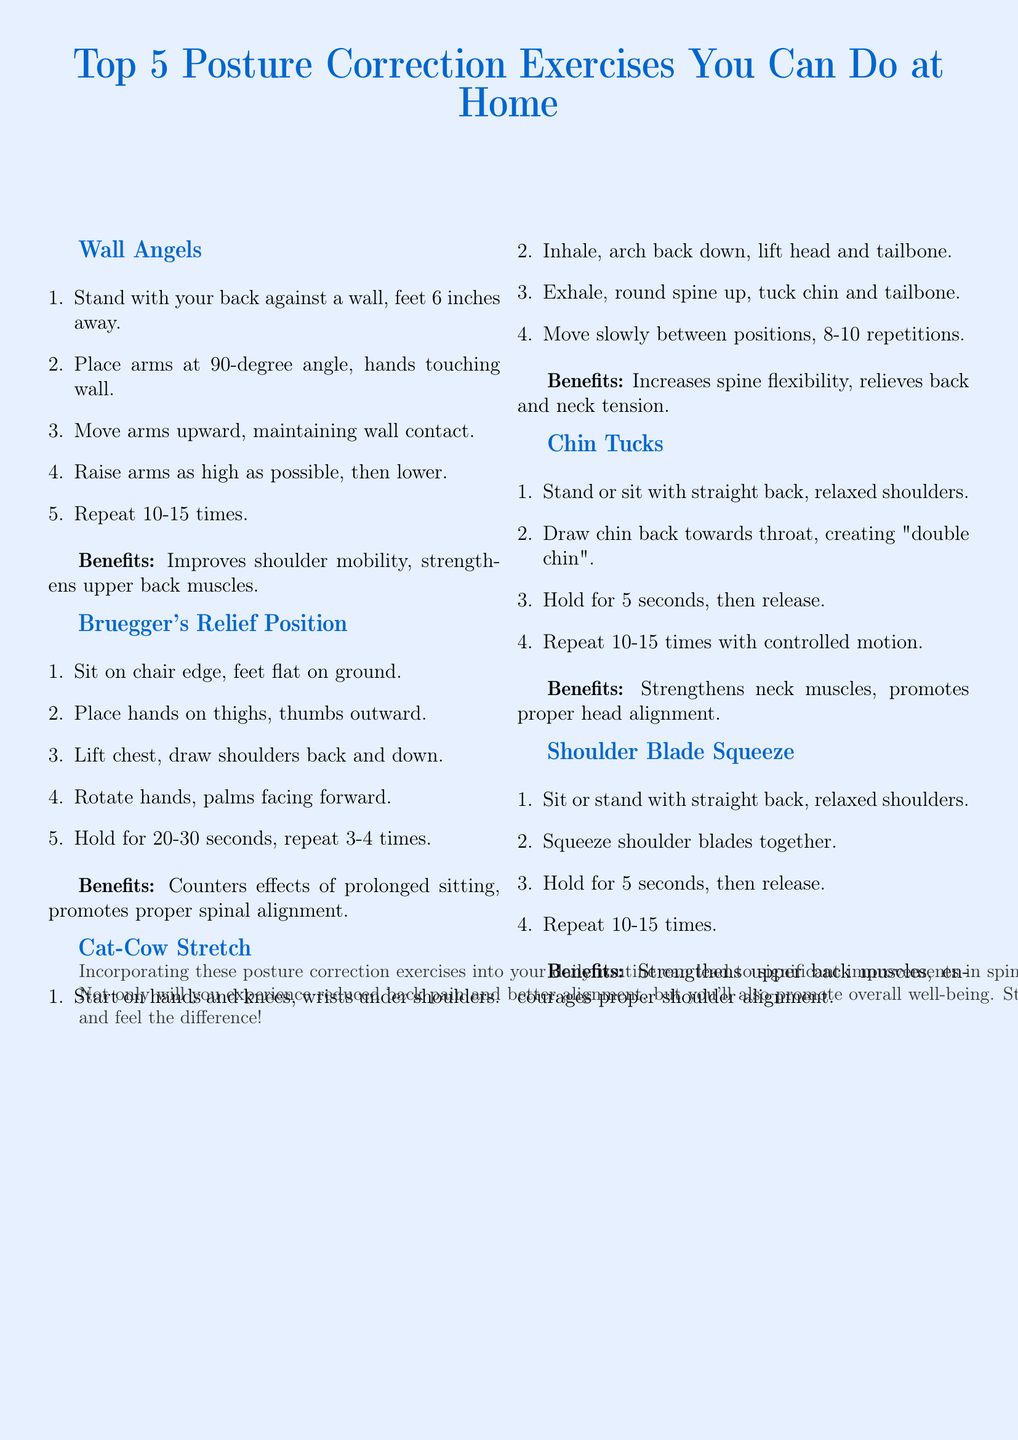What are the top posture correction exercises? The document lists the top five exercises aimed at improving posture: Wall Angels, Bruegger's Relief Position, Cat-Cow Stretch, Chin Tucks, and Shoulder Blade Squeeze.
Answer: Wall Angels, Bruegger's Relief Position, Cat-Cow Stretch, Chin Tucks, Shoulder Blade Squeeze How many repetitions are suggested for Wall Angels? The instructions for Wall Angels indicate that you should repeat the exercise 10-15 times.
Answer: 10-15 times What is a primary benefit of the Chin Tucks exercise? The document states that Chin Tucks strengthen neck muscles and promote proper head alignment.
Answer: Strengthens neck muscles, promotes proper head alignment Which exercise is recommended for improving shoulder mobility? The benefit listed for Wall Angels includes improving shoulder mobility and strengthening upper back muscles.
Answer: Wall Angels How many times should you hold the Bruegger's Relief Position? The instructions suggest holding the position for 20-30 seconds and repeating it 3-4 times.
Answer: 3-4 times What is the overall benefit of incorporating these exercises? The document explains that incorporating these exercises can lead to significant improvements in spinal health and overall well-being.
Answer: Significant improvements in spinal health What posture-related problems do these exercises target? The flyer addresses issues like back pain and improper spinal alignment, highlighting that the exercises help to relieve these problems.
Answer: Back pain, improper spinal alignment What posture correction exercise involves arching and rounding the back? The exercise that involves arching the back down and rounding it up is the Cat-Cow Stretch.
Answer: Cat-Cow Stretch 